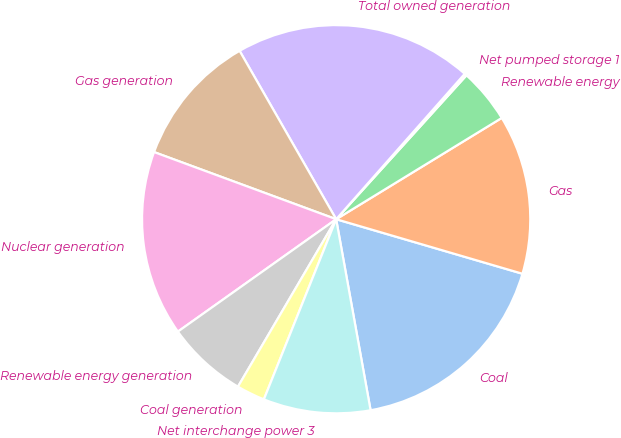<chart> <loc_0><loc_0><loc_500><loc_500><pie_chart><fcel>Coal<fcel>Gas<fcel>Renewable energy<fcel>Net pumped storage 1<fcel>Total owned generation<fcel>Gas generation<fcel>Nuclear generation<fcel>Renewable energy generation<fcel>Coal generation<fcel>Net interchange power 3<nl><fcel>17.63%<fcel>13.27%<fcel>4.55%<fcel>0.19%<fcel>19.81%<fcel>11.09%<fcel>15.45%<fcel>6.73%<fcel>2.37%<fcel>8.91%<nl></chart> 